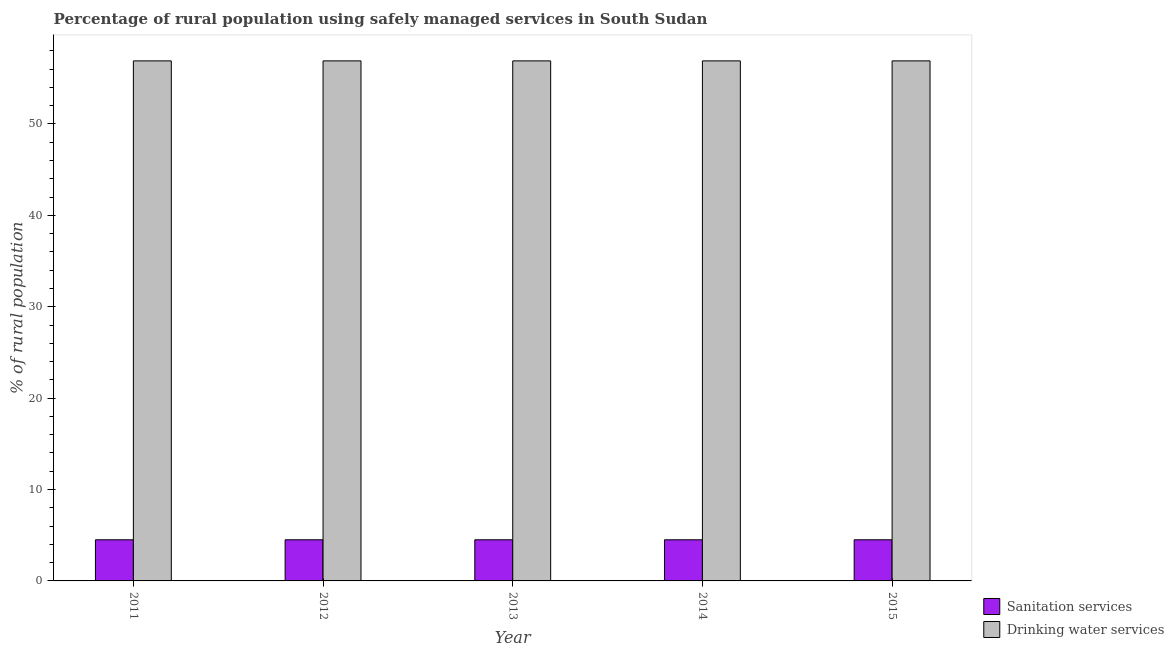How many groups of bars are there?
Provide a succinct answer. 5. Are the number of bars per tick equal to the number of legend labels?
Ensure brevity in your answer.  Yes. Are the number of bars on each tick of the X-axis equal?
Make the answer very short. Yes. How many bars are there on the 3rd tick from the left?
Make the answer very short. 2. How many bars are there on the 2nd tick from the right?
Make the answer very short. 2. In how many cases, is the number of bars for a given year not equal to the number of legend labels?
Keep it short and to the point. 0. What is the percentage of rural population who used sanitation services in 2013?
Make the answer very short. 4.5. Across all years, what is the maximum percentage of rural population who used sanitation services?
Your response must be concise. 4.5. Across all years, what is the minimum percentage of rural population who used sanitation services?
Make the answer very short. 4.5. In which year was the percentage of rural population who used drinking water services maximum?
Provide a succinct answer. 2011. What is the total percentage of rural population who used drinking water services in the graph?
Provide a short and direct response. 284.5. What is the difference between the percentage of rural population who used sanitation services in 2011 and that in 2014?
Provide a short and direct response. 0. What is the average percentage of rural population who used drinking water services per year?
Give a very brief answer. 56.9. What is the difference between the highest and the second highest percentage of rural population who used drinking water services?
Provide a succinct answer. 0. What does the 2nd bar from the left in 2013 represents?
Ensure brevity in your answer.  Drinking water services. What does the 1st bar from the right in 2015 represents?
Provide a short and direct response. Drinking water services. Are all the bars in the graph horizontal?
Your answer should be compact. No. How many years are there in the graph?
Keep it short and to the point. 5. Are the values on the major ticks of Y-axis written in scientific E-notation?
Keep it short and to the point. No. Does the graph contain any zero values?
Provide a succinct answer. No. Where does the legend appear in the graph?
Ensure brevity in your answer.  Bottom right. How many legend labels are there?
Provide a short and direct response. 2. How are the legend labels stacked?
Give a very brief answer. Vertical. What is the title of the graph?
Your answer should be compact. Percentage of rural population using safely managed services in South Sudan. Does "Food" appear as one of the legend labels in the graph?
Provide a succinct answer. No. What is the label or title of the Y-axis?
Offer a terse response. % of rural population. What is the % of rural population of Sanitation services in 2011?
Ensure brevity in your answer.  4.5. What is the % of rural population in Drinking water services in 2011?
Make the answer very short. 56.9. What is the % of rural population in Drinking water services in 2012?
Keep it short and to the point. 56.9. What is the % of rural population in Drinking water services in 2013?
Make the answer very short. 56.9. What is the % of rural population of Sanitation services in 2014?
Offer a very short reply. 4.5. What is the % of rural population in Drinking water services in 2014?
Ensure brevity in your answer.  56.9. What is the % of rural population in Sanitation services in 2015?
Your answer should be very brief. 4.5. What is the % of rural population in Drinking water services in 2015?
Make the answer very short. 56.9. Across all years, what is the maximum % of rural population in Sanitation services?
Provide a succinct answer. 4.5. Across all years, what is the maximum % of rural population in Drinking water services?
Offer a very short reply. 56.9. Across all years, what is the minimum % of rural population in Sanitation services?
Your answer should be compact. 4.5. Across all years, what is the minimum % of rural population of Drinking water services?
Your response must be concise. 56.9. What is the total % of rural population in Drinking water services in the graph?
Ensure brevity in your answer.  284.5. What is the difference between the % of rural population of Sanitation services in 2011 and that in 2012?
Your response must be concise. 0. What is the difference between the % of rural population in Sanitation services in 2011 and that in 2013?
Offer a terse response. 0. What is the difference between the % of rural population in Drinking water services in 2011 and that in 2015?
Ensure brevity in your answer.  0. What is the difference between the % of rural population of Drinking water services in 2012 and that in 2013?
Offer a terse response. 0. What is the difference between the % of rural population of Drinking water services in 2012 and that in 2014?
Keep it short and to the point. 0. What is the difference between the % of rural population in Drinking water services in 2013 and that in 2014?
Provide a short and direct response. 0. What is the difference between the % of rural population in Drinking water services in 2013 and that in 2015?
Offer a terse response. 0. What is the difference between the % of rural population of Sanitation services in 2014 and that in 2015?
Your response must be concise. 0. What is the difference between the % of rural population of Drinking water services in 2014 and that in 2015?
Give a very brief answer. 0. What is the difference between the % of rural population in Sanitation services in 2011 and the % of rural population in Drinking water services in 2012?
Keep it short and to the point. -52.4. What is the difference between the % of rural population in Sanitation services in 2011 and the % of rural population in Drinking water services in 2013?
Your response must be concise. -52.4. What is the difference between the % of rural population in Sanitation services in 2011 and the % of rural population in Drinking water services in 2014?
Provide a succinct answer. -52.4. What is the difference between the % of rural population of Sanitation services in 2011 and the % of rural population of Drinking water services in 2015?
Provide a succinct answer. -52.4. What is the difference between the % of rural population of Sanitation services in 2012 and the % of rural population of Drinking water services in 2013?
Your response must be concise. -52.4. What is the difference between the % of rural population of Sanitation services in 2012 and the % of rural population of Drinking water services in 2014?
Offer a terse response. -52.4. What is the difference between the % of rural population in Sanitation services in 2012 and the % of rural population in Drinking water services in 2015?
Your answer should be very brief. -52.4. What is the difference between the % of rural population in Sanitation services in 2013 and the % of rural population in Drinking water services in 2014?
Your answer should be compact. -52.4. What is the difference between the % of rural population in Sanitation services in 2013 and the % of rural population in Drinking water services in 2015?
Your response must be concise. -52.4. What is the difference between the % of rural population in Sanitation services in 2014 and the % of rural population in Drinking water services in 2015?
Give a very brief answer. -52.4. What is the average % of rural population in Sanitation services per year?
Provide a succinct answer. 4.5. What is the average % of rural population of Drinking water services per year?
Your response must be concise. 56.9. In the year 2011, what is the difference between the % of rural population in Sanitation services and % of rural population in Drinking water services?
Offer a terse response. -52.4. In the year 2012, what is the difference between the % of rural population of Sanitation services and % of rural population of Drinking water services?
Your answer should be very brief. -52.4. In the year 2013, what is the difference between the % of rural population of Sanitation services and % of rural population of Drinking water services?
Give a very brief answer. -52.4. In the year 2014, what is the difference between the % of rural population in Sanitation services and % of rural population in Drinking water services?
Provide a short and direct response. -52.4. In the year 2015, what is the difference between the % of rural population of Sanitation services and % of rural population of Drinking water services?
Your answer should be compact. -52.4. What is the ratio of the % of rural population in Sanitation services in 2011 to that in 2012?
Offer a very short reply. 1. What is the ratio of the % of rural population of Sanitation services in 2011 to that in 2015?
Ensure brevity in your answer.  1. What is the ratio of the % of rural population of Drinking water services in 2011 to that in 2015?
Give a very brief answer. 1. What is the ratio of the % of rural population of Drinking water services in 2012 to that in 2013?
Your response must be concise. 1. What is the ratio of the % of rural population of Sanitation services in 2012 to that in 2014?
Provide a short and direct response. 1. What is the ratio of the % of rural population in Sanitation services in 2012 to that in 2015?
Offer a very short reply. 1. What is the ratio of the % of rural population in Sanitation services in 2013 to that in 2014?
Provide a short and direct response. 1. What is the ratio of the % of rural population of Drinking water services in 2013 to that in 2014?
Your response must be concise. 1. What is the ratio of the % of rural population in Sanitation services in 2013 to that in 2015?
Give a very brief answer. 1. What is the ratio of the % of rural population of Drinking water services in 2014 to that in 2015?
Provide a short and direct response. 1. What is the difference between the highest and the lowest % of rural population in Sanitation services?
Provide a succinct answer. 0. What is the difference between the highest and the lowest % of rural population in Drinking water services?
Your answer should be very brief. 0. 